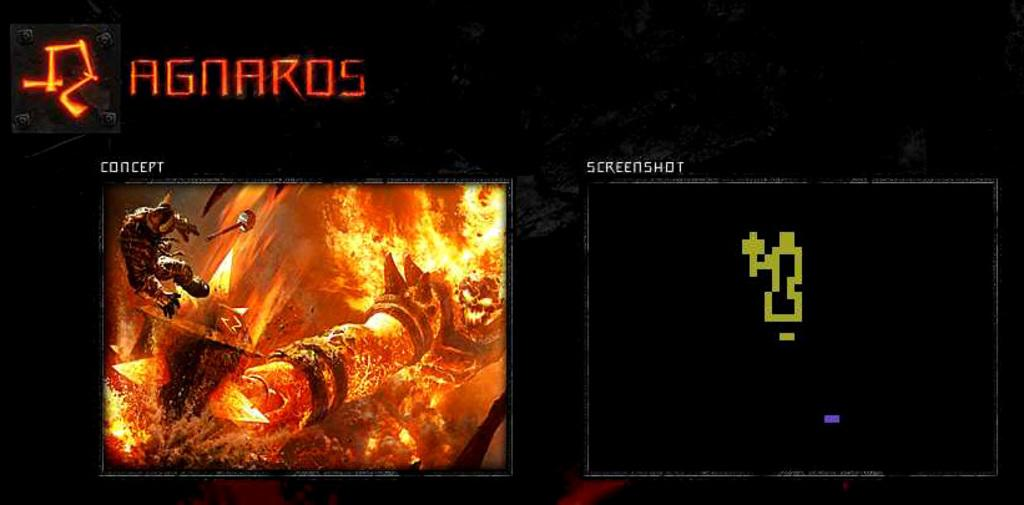<image>
Provide a brief description of the given image. A game being shown on a concept tv next to another tv. 